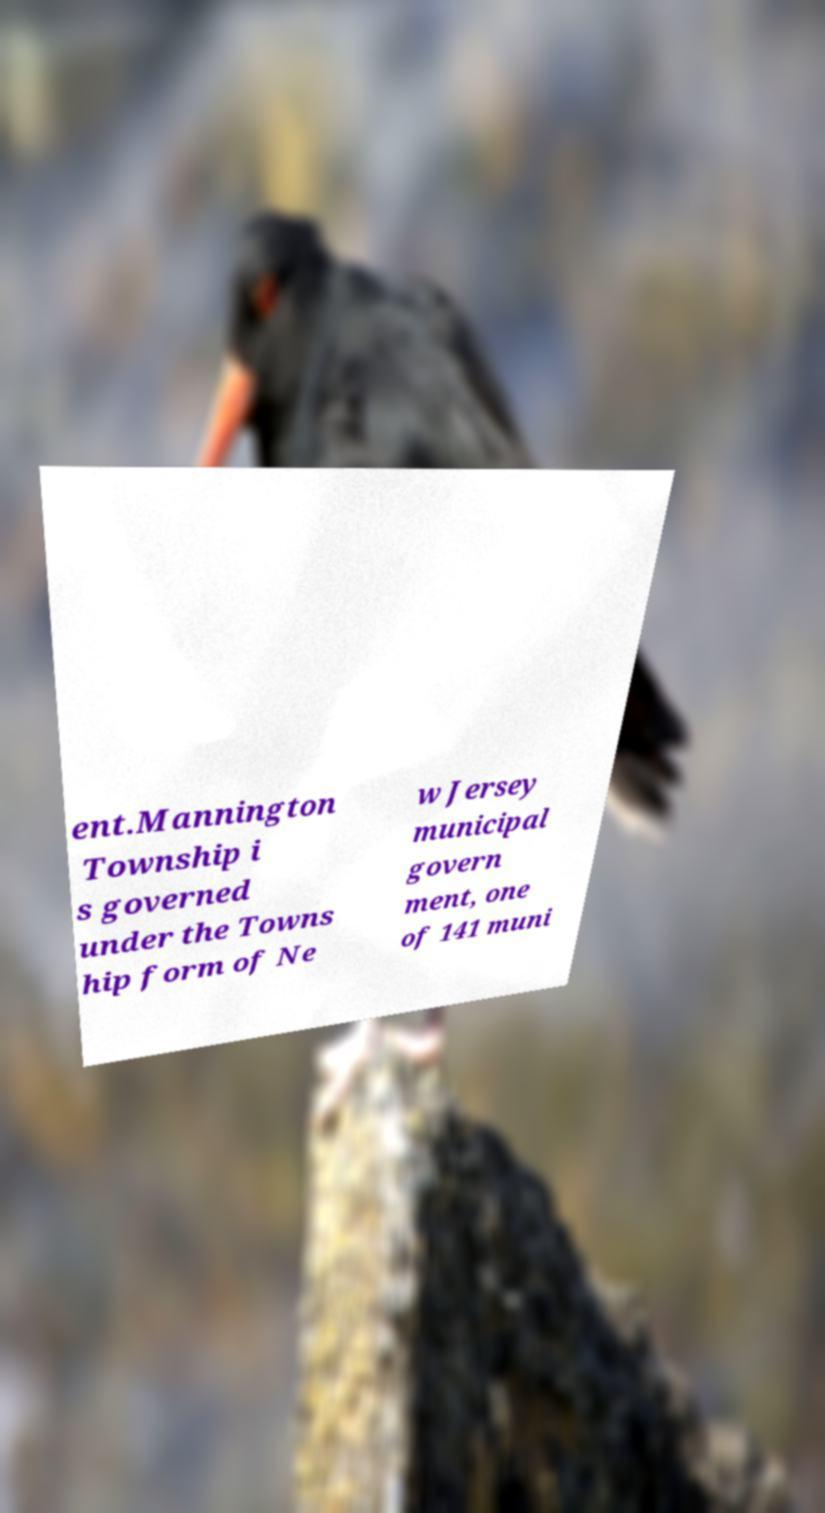Can you accurately transcribe the text from the provided image for me? ent.Mannington Township i s governed under the Towns hip form of Ne w Jersey municipal govern ment, one of 141 muni 